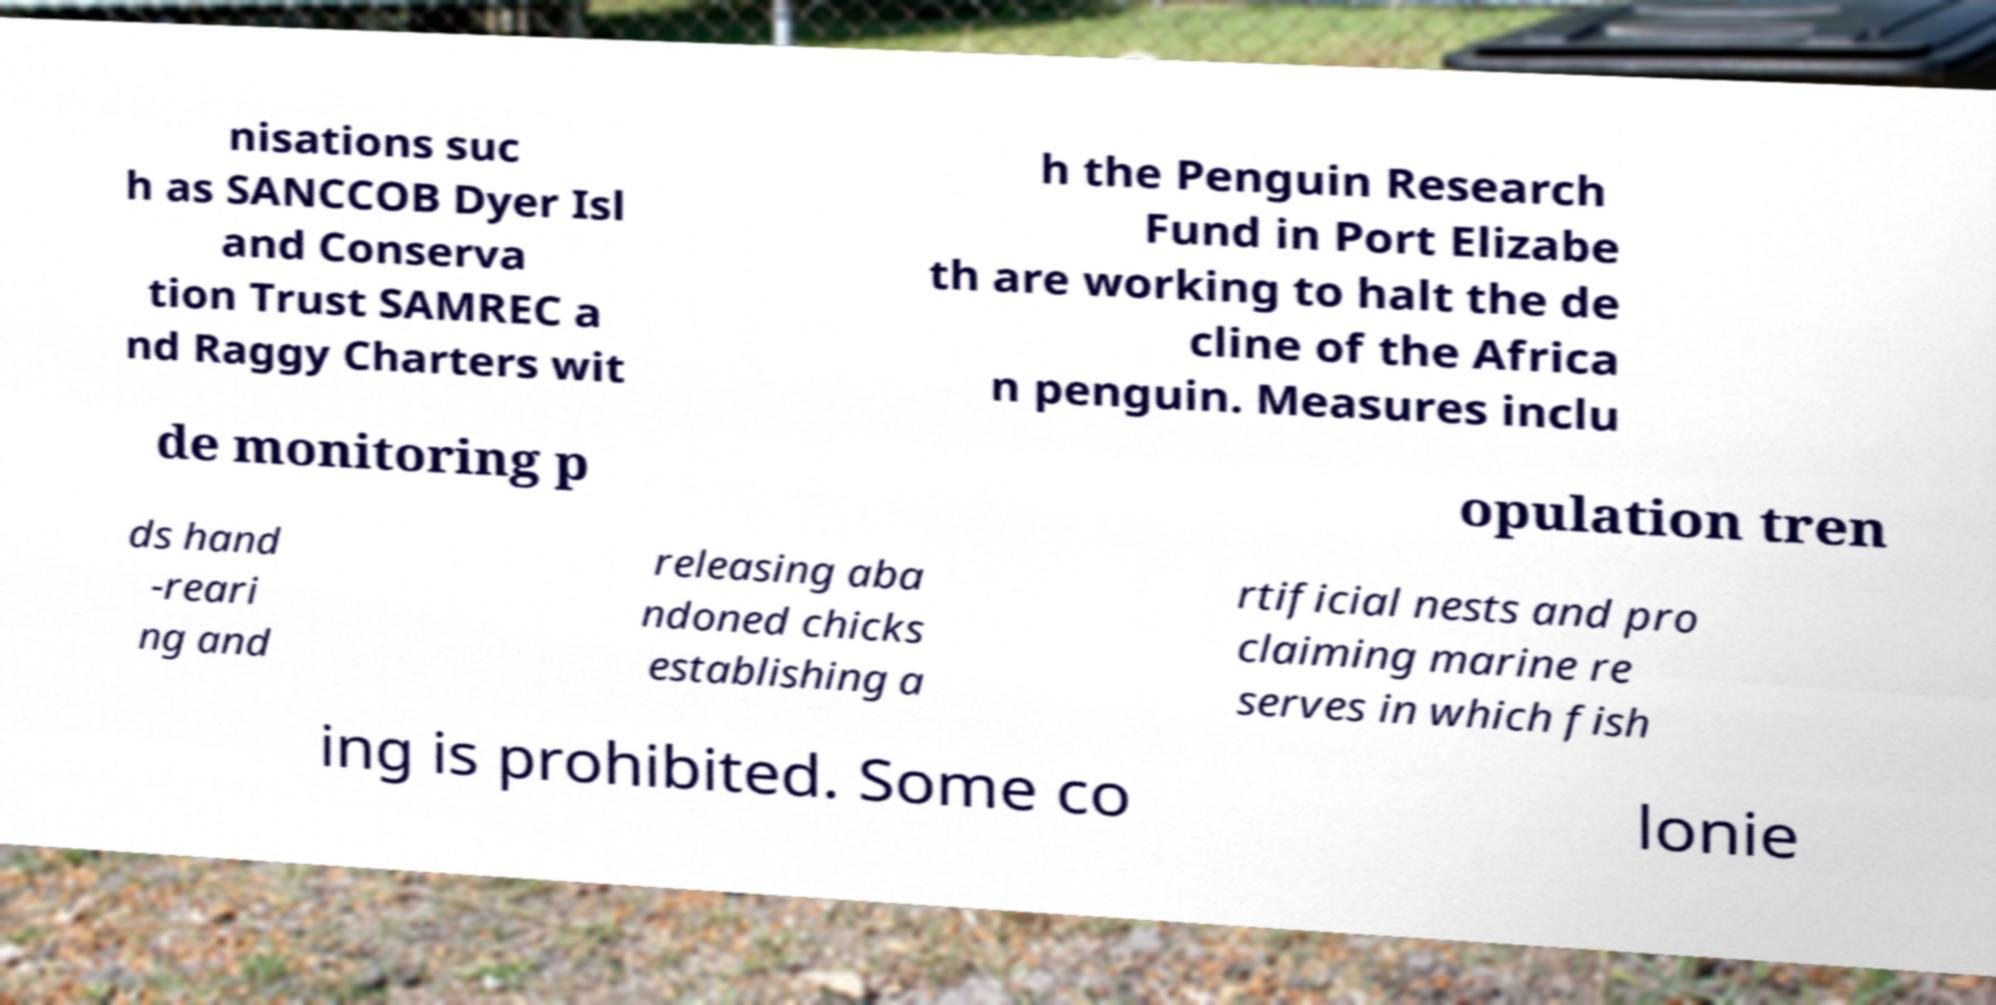Could you extract and type out the text from this image? nisations suc h as SANCCOB Dyer Isl and Conserva tion Trust SAMREC a nd Raggy Charters wit h the Penguin Research Fund in Port Elizabe th are working to halt the de cline of the Africa n penguin. Measures inclu de monitoring p opulation tren ds hand -reari ng and releasing aba ndoned chicks establishing a rtificial nests and pro claiming marine re serves in which fish ing is prohibited. Some co lonie 